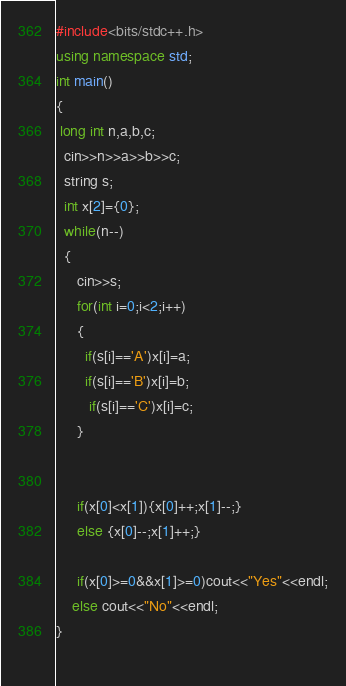<code> <loc_0><loc_0><loc_500><loc_500><_C++_>#include<bits/stdc++.h>
using namespace std;
int main()
{
 long int n,a,b,c;
  cin>>n>>a>>b>>c;
  string s;
  int x[2]={0};
  while(n--)
  {
     cin>>s;
     for(int i=0;i<2;i++)
     {
       if(s[i]=='A')x[i]=a;
       if(s[i]=='B')x[i]=b;
        if(s[i]=='C')x[i]=c;
     }
  
    
     if(x[0]<x[1]){x[0]++;x[1]--;}
     else {x[0]--;x[1]++;}
       
     if(x[0]>=0&&x[1]>=0)cout<<"Yes"<<endl;
    else cout<<"No"<<endl;
}
      
</code> 